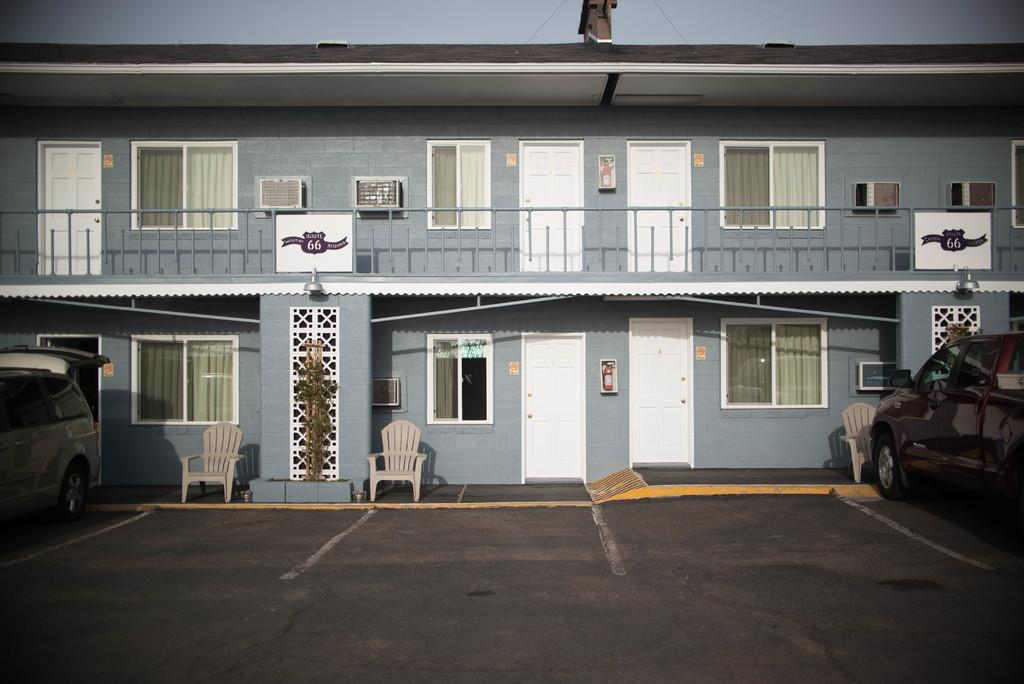What type of structure is present in the image? There is a building in the image. What are the possible entry points into the building? There are doors in the image. What types of transportation are visible in the image? There are vehicles in the image. What can be used for ventilation or observation in the building? There are windows in the image. What type of furniture is present in the image? There are chairs in the image. What architectural feature can be seen on the building? There is a grille in the image. What safety equipment is present in the image? There are hydrants in the image. What can be seen above the building? The sky is visible in the image. Can you see a crook in the image? No, there is no crook present in the image. 